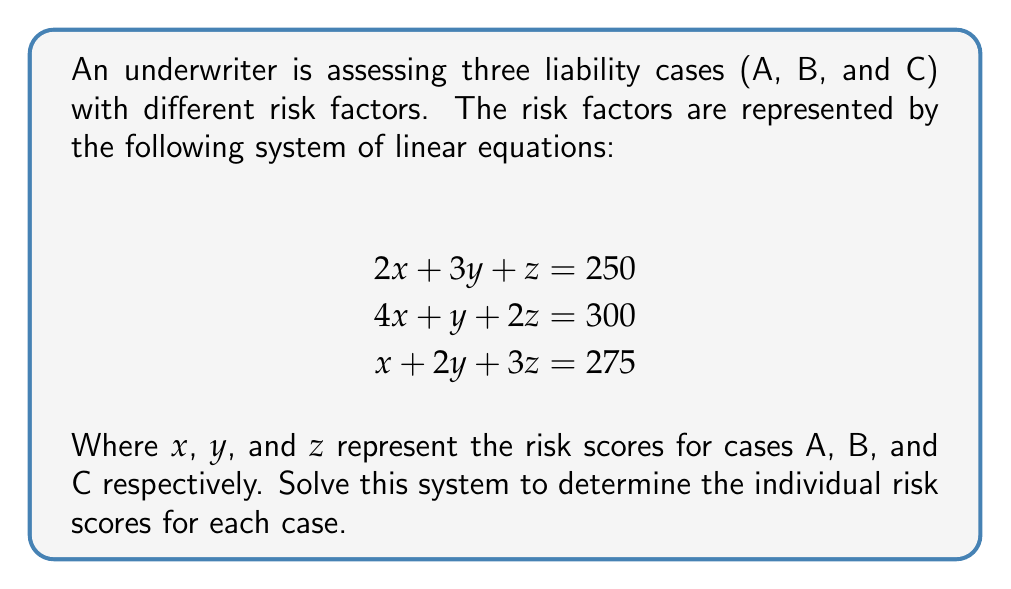Solve this math problem. To solve this system of linear equations, we'll use the Gaussian elimination method:

1) First, write the augmented matrix:

$$\begin{bmatrix}
2 & 3 & 1 & 250 \\
4 & 1 & 2 & 300 \\
1 & 2 & 3 & 275
\end{bmatrix}$$

2) Multiply the first row by -2 and add it to the second row:

$$\begin{bmatrix}
2 & 3 & 1 & 250 \\
0 & -5 & 0 & -200 \\
1 & 2 & 3 & 275
\end{bmatrix}$$

3) Multiply the first row by -1/2 and add it to the third row:

$$\begin{bmatrix}
2 & 3 & 1 & 250 \\
0 & -5 & 0 & -200 \\
0 & 1/2 & 5/2 & 150
\end{bmatrix}$$

4) Multiply the second row by -1/10 and add it to the third row:

$$\begin{bmatrix}
2 & 3 & 1 & 250 \\
0 & -5 & 0 & -200 \\
0 & 0 & 5/2 & 170
\end{bmatrix}$$

5) Now we have an upper triangular matrix. Solve for $z$:

$\frac{5}{2}z = 170$
$z = 68$

6) Substitute $z$ into the second equation:

$-5y = -200$
$y = 40$

7) Substitute $y$ and $z$ into the first equation:

$2x + 3(40) + 68 = 250$
$2x + 120 + 68 = 250$
$2x = 62$
$x = 31$

Therefore, the risk scores are:
$x = 31$ (Case A)
$y = 40$ (Case B)
$z = 68$ (Case C)
Answer: Case A: 31, Case B: 40, Case C: 68 